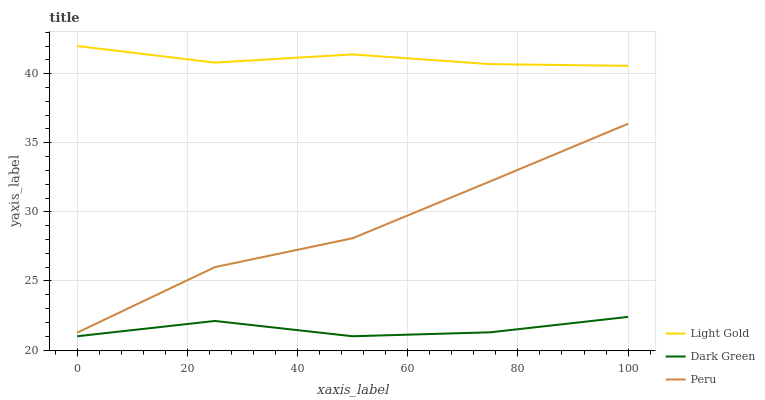Does Dark Green have the minimum area under the curve?
Answer yes or no. Yes. Does Light Gold have the maximum area under the curve?
Answer yes or no. Yes. Does Peru have the minimum area under the curve?
Answer yes or no. No. Does Peru have the maximum area under the curve?
Answer yes or no. No. Is Light Gold the smoothest?
Answer yes or no. Yes. Is Peru the roughest?
Answer yes or no. Yes. Is Dark Green the smoothest?
Answer yes or no. No. Is Dark Green the roughest?
Answer yes or no. No. Does Peru have the lowest value?
Answer yes or no. No. Does Peru have the highest value?
Answer yes or no. No. Is Dark Green less than Peru?
Answer yes or no. Yes. Is Light Gold greater than Dark Green?
Answer yes or no. Yes. Does Dark Green intersect Peru?
Answer yes or no. No. 